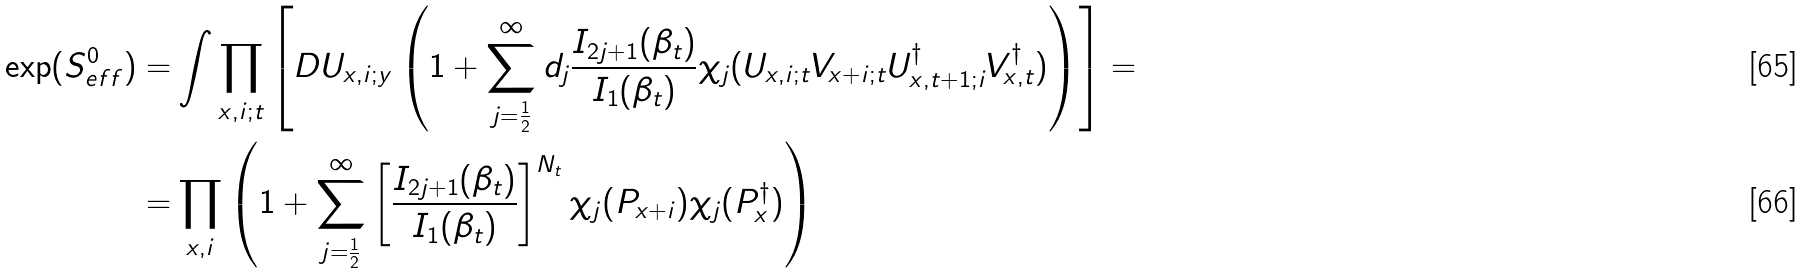<formula> <loc_0><loc_0><loc_500><loc_500>\exp ( S _ { e f f } ^ { 0 } ) = & \int \prod _ { x , i ; t } \left [ D U _ { x , i ; y } \left ( 1 + \sum _ { j = \frac { 1 } { 2 } } ^ { \infty } d _ { j } \frac { I _ { 2 j + 1 } ( \beta _ { t } ) } { I _ { 1 } ( \beta _ { t } ) } \chi _ { j } ( U _ { x , i ; t } V _ { x + i ; t } U ^ { \dag } _ { x , t + 1 ; i } V ^ { \dag } _ { x , t } ) \right ) \right ] = \\ = & \prod _ { x , i } \left ( 1 + \sum _ { j = \frac { 1 } { 2 } } ^ { \infty } \left [ \frac { I _ { 2 j + 1 } ( \beta _ { t } ) } { I _ { 1 } ( \beta _ { t } ) } \right ] ^ { N _ { t } } \chi _ { j } ( P _ { x + i } ) \chi _ { j } ( P _ { x } ^ { \dag } ) \right )</formula> 